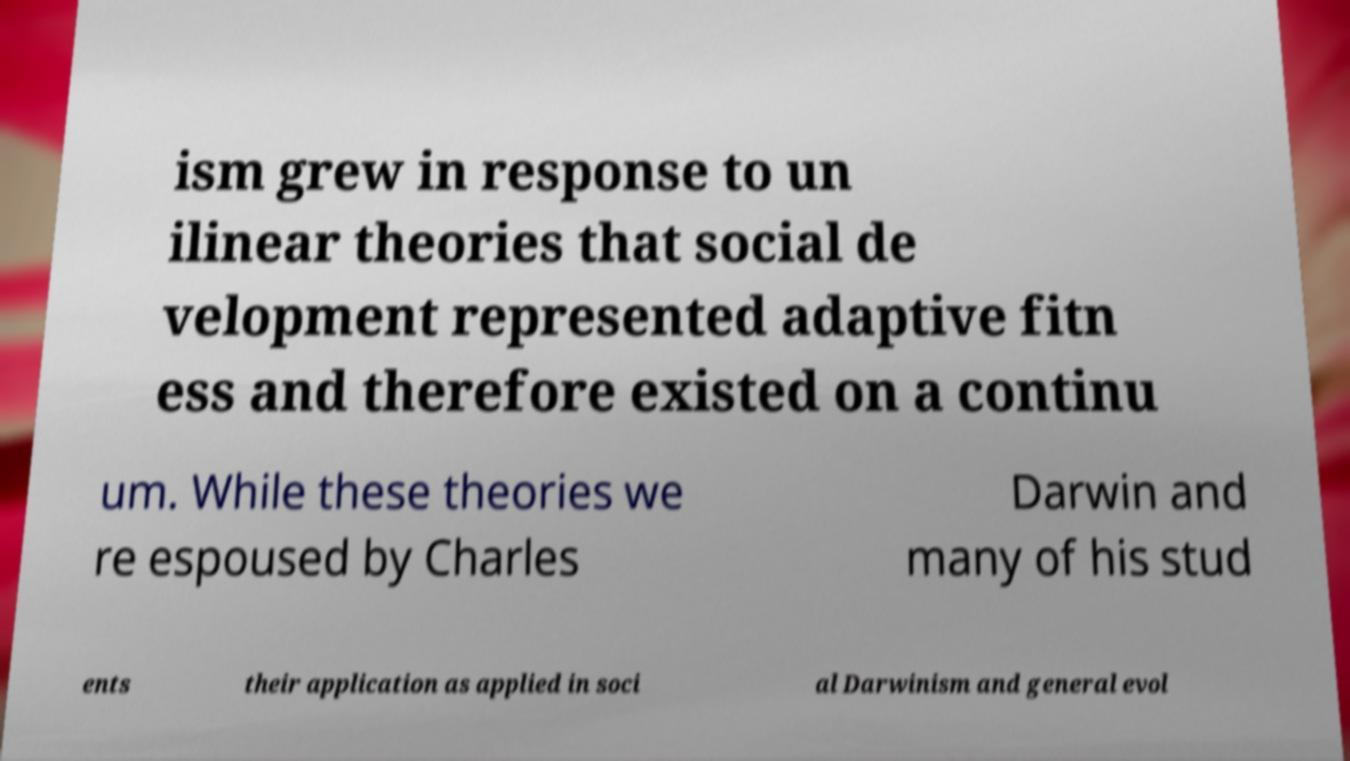Could you assist in decoding the text presented in this image and type it out clearly? ism grew in response to un ilinear theories that social de velopment represented adaptive fitn ess and therefore existed on a continu um. While these theories we re espoused by Charles Darwin and many of his stud ents their application as applied in soci al Darwinism and general evol 